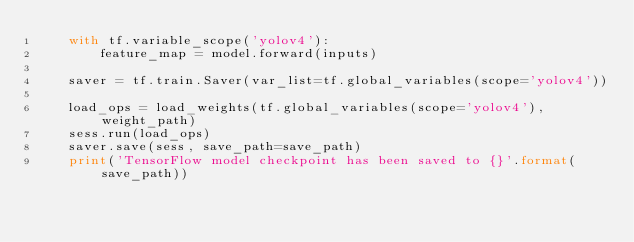Convert code to text. <code><loc_0><loc_0><loc_500><loc_500><_Python_>    with tf.variable_scope('yolov4'):
        feature_map = model.forward(inputs)

    saver = tf.train.Saver(var_list=tf.global_variables(scope='yolov4'))

    load_ops = load_weights(tf.global_variables(scope='yolov4'), weight_path)
    sess.run(load_ops)
    saver.save(sess, save_path=save_path)
    print('TensorFlow model checkpoint has been saved to {}'.format(save_path))
</code> 